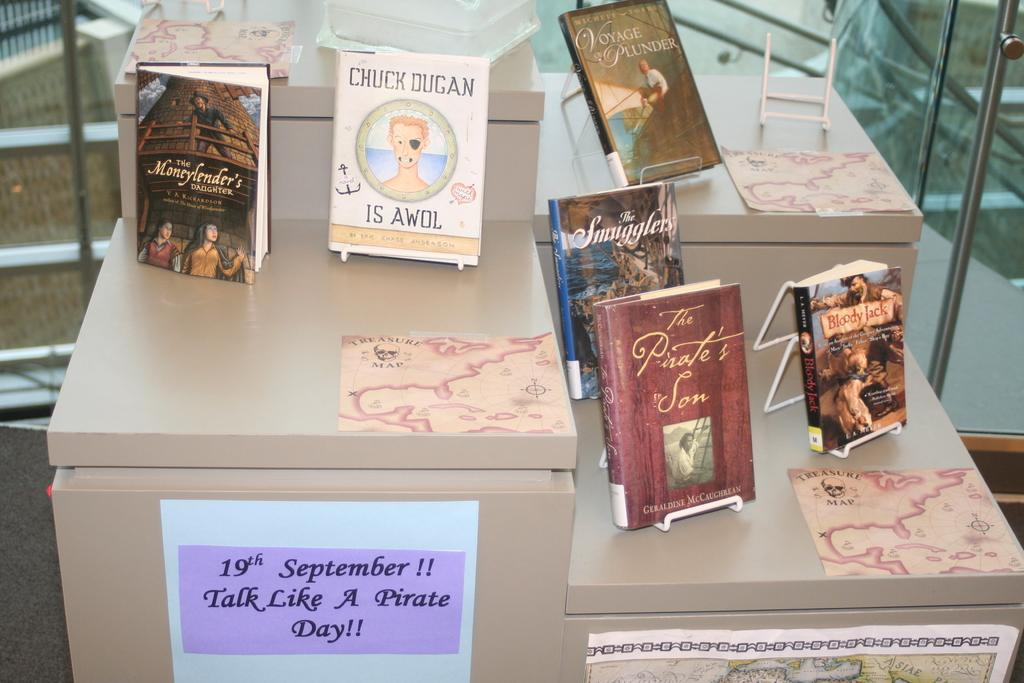<image>
Describe the image concisely. A small collection of books for Talk Like a Pirate Day on September 19. 